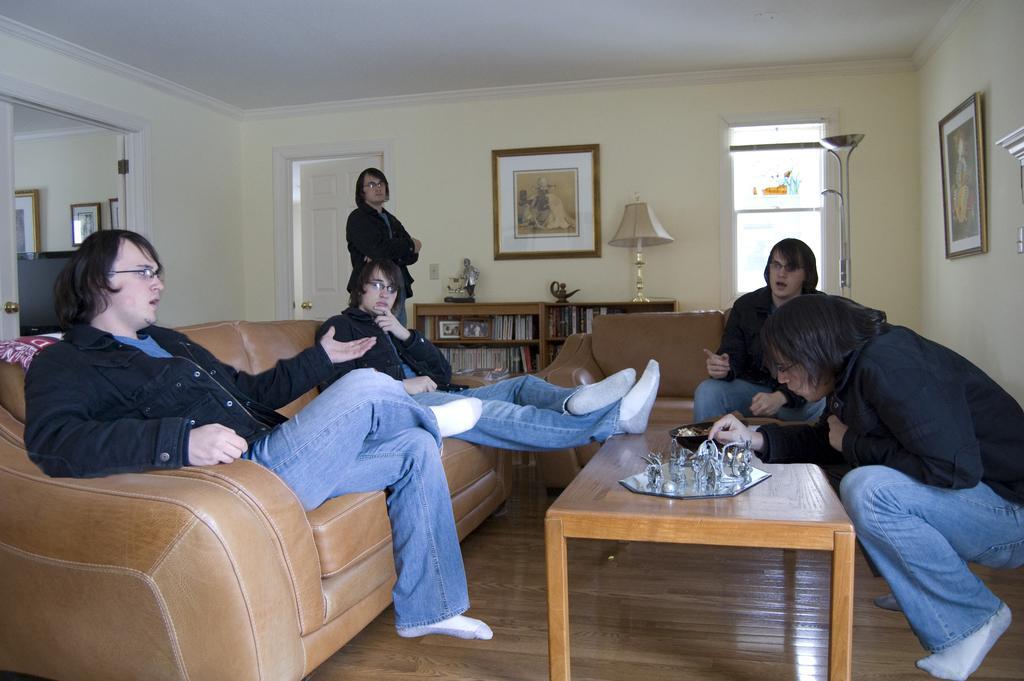Please provide a concise description of this image. There are few people sitting on the sofa. In the background there is a person standing at the door,there are frames on the wall,tables,window and a lamp. 